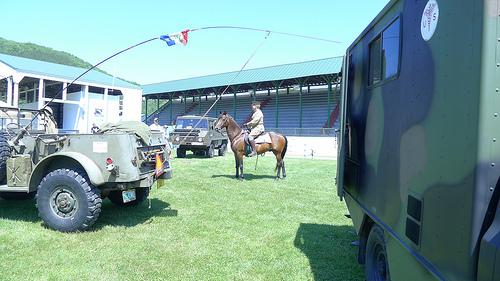Question: what color is the sky?
Choices:
A. Gray.
B. Red and orange.
C. Blue.
D. Black.
Answer with the letter. Answer: C 